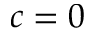<formula> <loc_0><loc_0><loc_500><loc_500>c = 0</formula> 